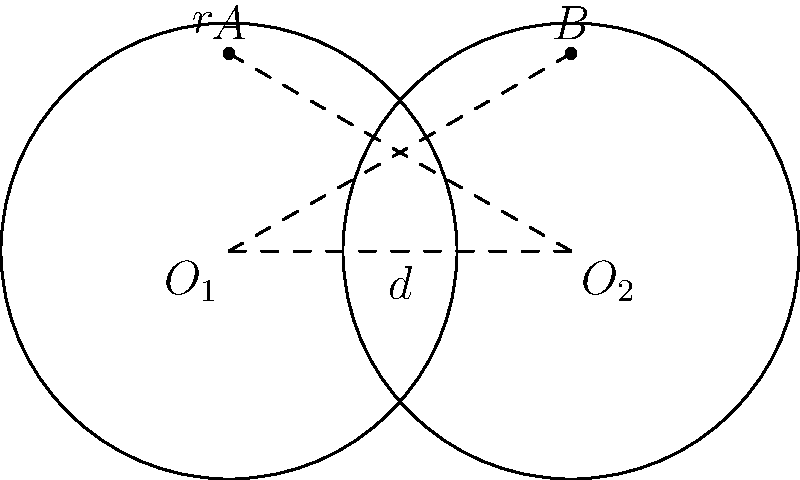As a bartender serving craft beers, you're arranging circular beer mats on the bar. Two identical beer mats with a radius of 2 inches overlap as shown in the diagram. If the centers of the mats are 3 inches apart, what is the area of the overlapping region (shaded area) in square inches? Round your answer to two decimal places. Let's approach this step-by-step:

1) First, we need to identify the shape of the overlapping region. It's called a lens, formed by the intersection of two circles.

2) The formula for the area of a lens is:
   $$A = 2r^2 \arccos(\frac{d}{2r}) - d\sqrt{r^2 - (\frac{d}{2})^2}$$
   where $r$ is the radius of the circles and $d$ is the distance between their centers.

3) We're given:
   $r = 2$ inches
   $d = 3$ inches

4) Let's substitute these values into our formula:
   $$A = 2(2^2) \arccos(\frac{3}{2(2)}) - 3\sqrt{2^2 - (\frac{3}{2})^2}$$

5) Simplify:
   $$A = 8 \arccos(\frac{3}{4}) - 3\sqrt{4 - \frac{9}{4}}$$
   $$A = 8 \arccos(\frac{3}{4}) - 3\sqrt{\frac{7}{4}}$$

6) Calculate:
   $$A \approx 8(0.7227) - 3(1.3229)$$
   $$A \approx 5.7816 - 3.9687$$
   $$A \approx 1.8129$$

7) Rounding to two decimal places:
   $$A \approx 1.81$$ square inches
Answer: 1.81 square inches 